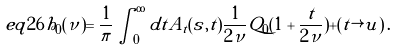<formula> <loc_0><loc_0><loc_500><loc_500>e q 2 6 \tilde { h } _ { 0 } ( \nu ) = \frac { 1 } { \pi } \int _ { 0 } ^ { \infty } d t \tilde { A } _ { t } ( s , t ) \frac { 1 } { 2 \nu } Q _ { 0 } ( 1 + \frac { t } { 2 \nu } ) + ( t \rightarrow u ) \, .</formula> 